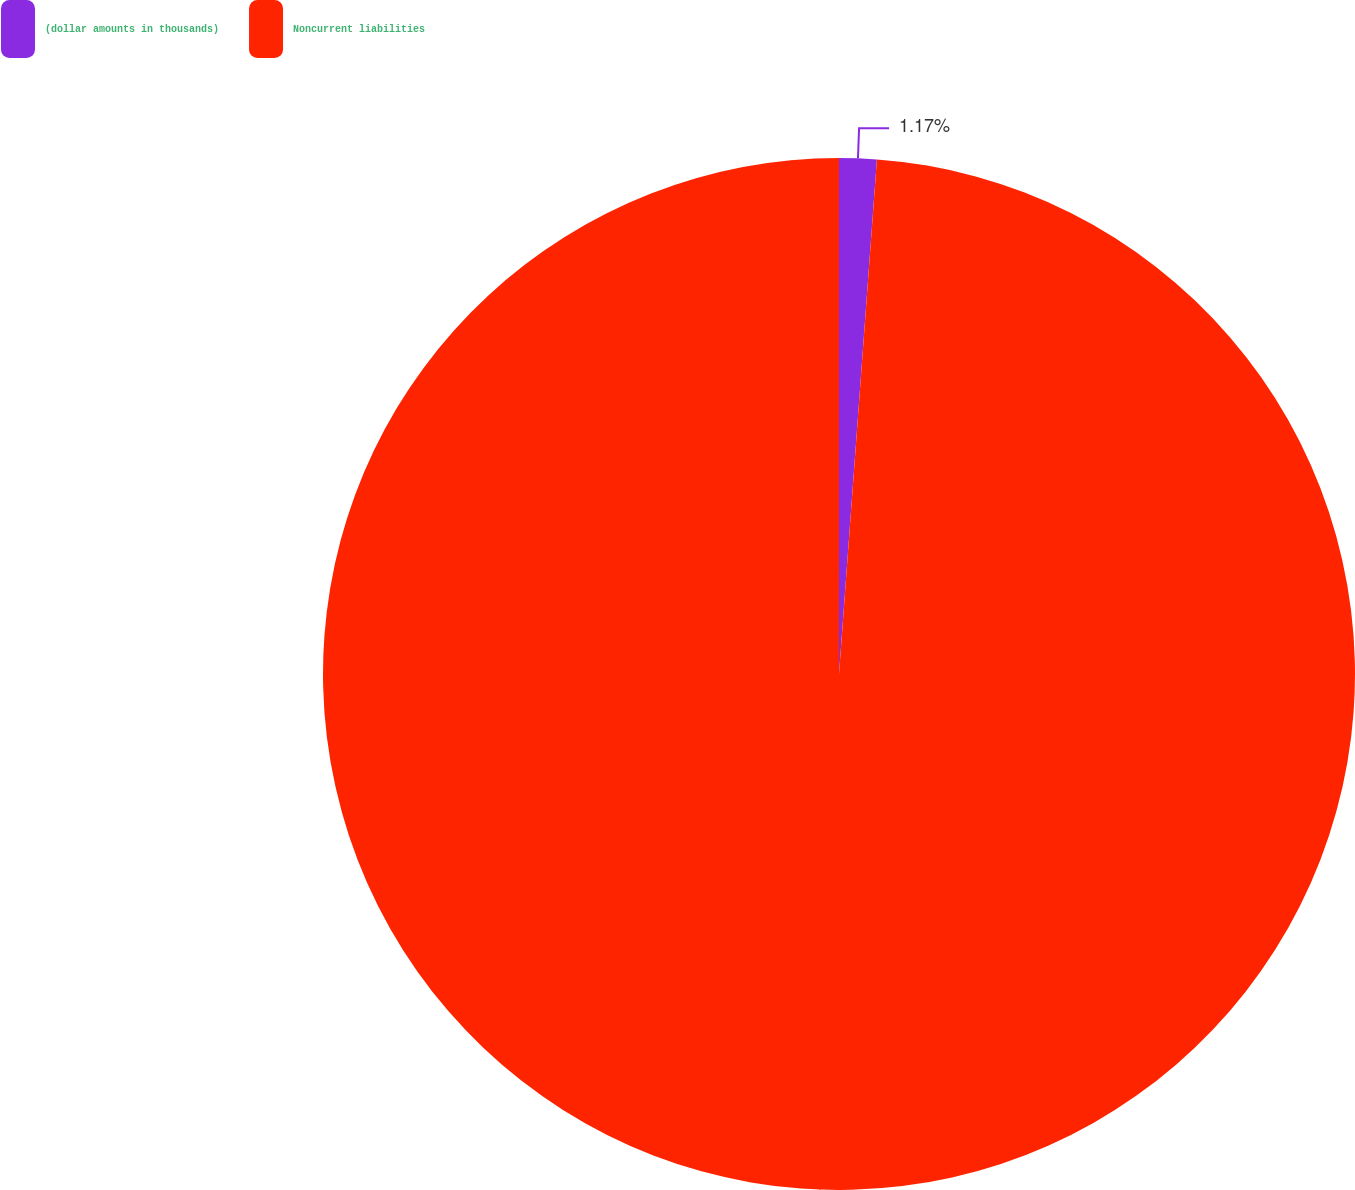Convert chart to OTSL. <chart><loc_0><loc_0><loc_500><loc_500><pie_chart><fcel>(dollar amounts in thousands)<fcel>Noncurrent liabilities<nl><fcel>1.17%<fcel>98.83%<nl></chart> 